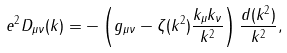<formula> <loc_0><loc_0><loc_500><loc_500>e ^ { 2 } D _ { \mu \nu } ( k ) = - \left ( g _ { \mu \nu } - \zeta ( k ^ { 2 } ) \frac { k _ { \mu } k _ { \nu } } { k ^ { 2 } } \right ) \frac { d ( k ^ { 2 } ) } { k ^ { 2 } } ,</formula> 